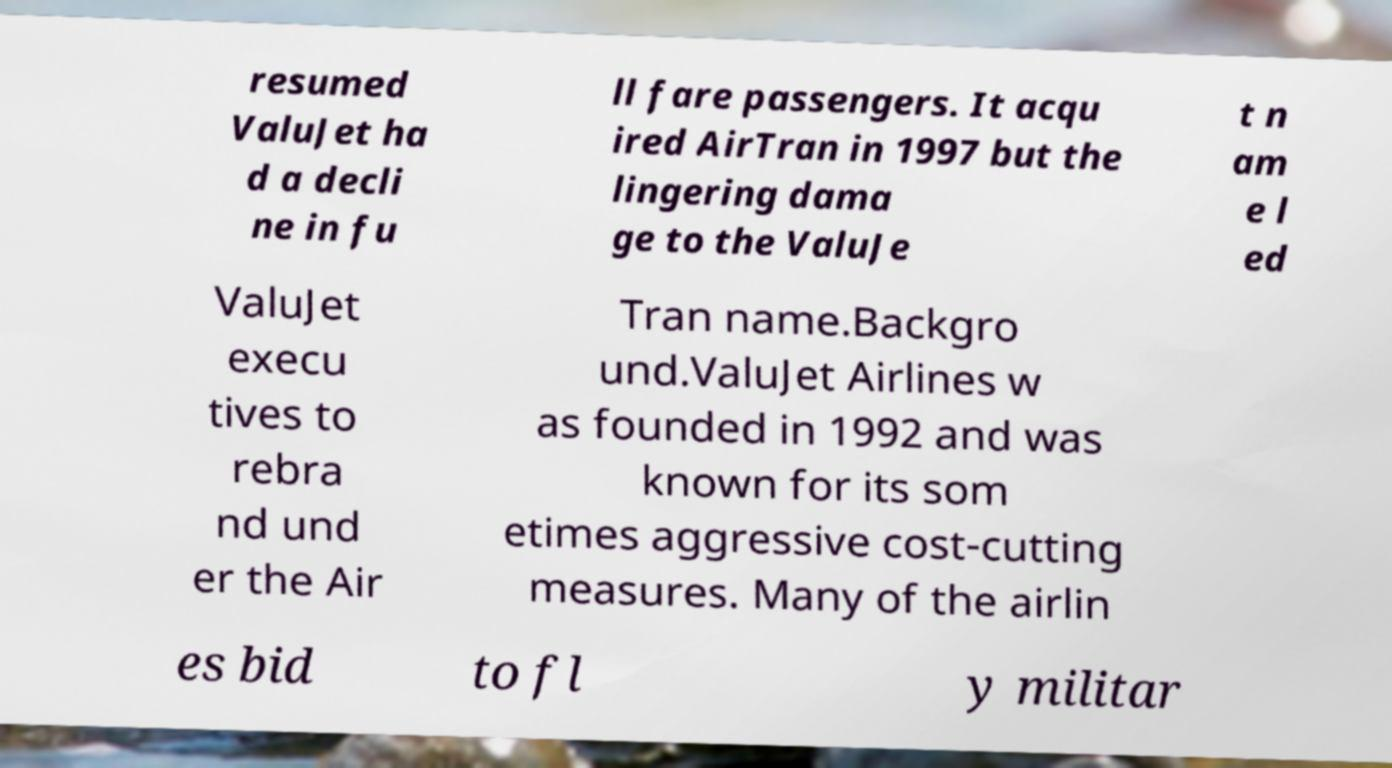For documentation purposes, I need the text within this image transcribed. Could you provide that? resumed ValuJet ha d a decli ne in fu ll fare passengers. It acqu ired AirTran in 1997 but the lingering dama ge to the ValuJe t n am e l ed ValuJet execu tives to rebra nd und er the Air Tran name.Backgro und.ValuJet Airlines w as founded in 1992 and was known for its som etimes aggressive cost-cutting measures. Many of the airlin es bid to fl y militar 